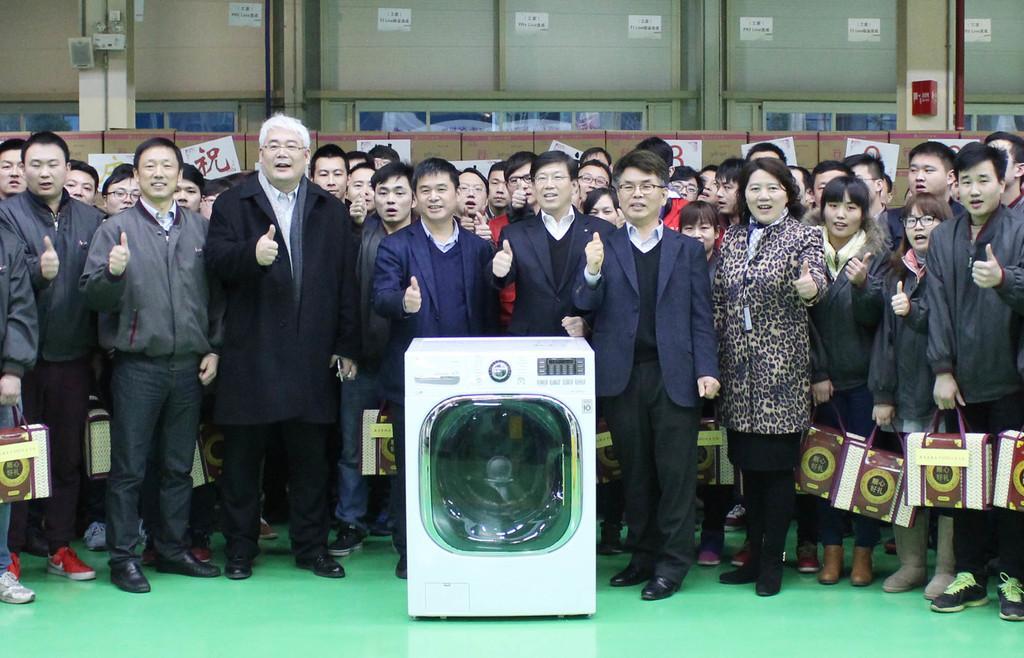Describe this image in one or two sentences. In this picture I can see a washing machine in front and behind it I see number of people who are standing and I see that few of them are holding bags. In the background I see the wall on which there are few papers and I see something is written on them. 